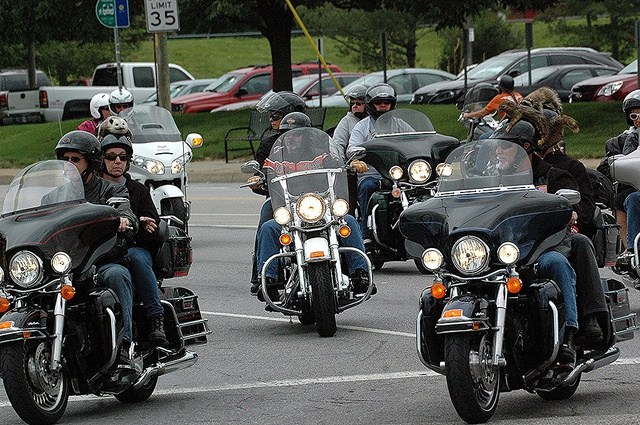Describe the objects in this image and their specific colors. I can see motorcycle in black, gray, darkgray, and white tones, motorcycle in black, gray, darkgray, and lightgray tones, motorcycle in black, gray, white, and darkgray tones, motorcycle in black, gray, darkgray, and white tones, and people in black, gray, blue, and navy tones in this image. 